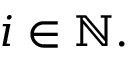Convert formula to latex. <formula><loc_0><loc_0><loc_500><loc_500>i \in \mathbb { N } .</formula> 